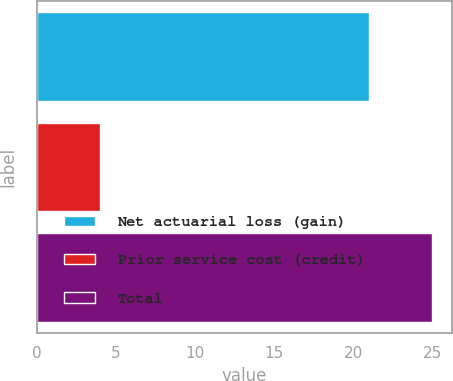<chart> <loc_0><loc_0><loc_500><loc_500><bar_chart><fcel>Net actuarial loss (gain)<fcel>Prior service cost (credit)<fcel>Total<nl><fcel>21<fcel>4<fcel>25<nl></chart> 